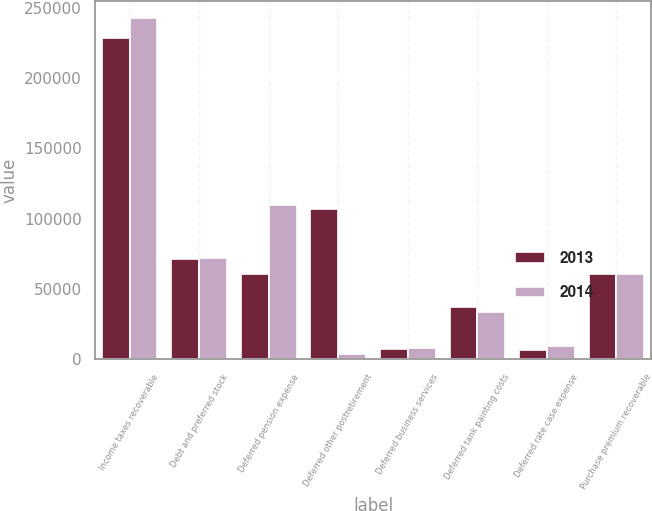Convert chart to OTSL. <chart><loc_0><loc_0><loc_500><loc_500><stacked_bar_chart><ecel><fcel>Income taxes recoverable<fcel>Debt and preferred stock<fcel>Deferred pension expense<fcel>Deferred other postretirement<fcel>Deferred business services<fcel>Deferred tank painting costs<fcel>Deferred rate case expense<fcel>Purchase premium recoverable<nl><fcel>2013<fcel>228601<fcel>71403<fcel>60412<fcel>106792<fcel>7530<fcel>37207<fcel>6785<fcel>60412<nl><fcel>2014<fcel>242902<fcel>72349<fcel>109799<fcel>3653<fcel>7763<fcel>33519<fcel>9407<fcel>60787<nl></chart> 